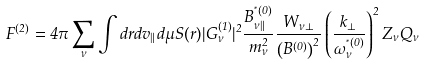Convert formula to latex. <formula><loc_0><loc_0><loc_500><loc_500>F ^ { ( 2 ) } = 4 \pi \sum _ { \nu } \int d r d v _ { \| } d \mu S ( r ) | G ^ { ( 1 ) } _ { \nu } | ^ { 2 } \frac { B ^ { ^ { * } { ( 0 ) } } _ { \nu \| } } { m ^ { 2 } _ { \nu } } \frac { W _ { \nu \perp } } { \left ( B ^ { ( 0 ) } \right ) ^ { 2 } } \left ( \frac { k _ { \perp } } { \omega ^ { ^ { * } { ( 0 ) } } _ { \nu } } \right ) ^ { 2 } Z _ { \nu } Q _ { \nu }</formula> 